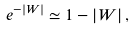Convert formula to latex. <formula><loc_0><loc_0><loc_500><loc_500>e ^ { - \left | W \right | } \simeq 1 - \left | W \right | ,</formula> 